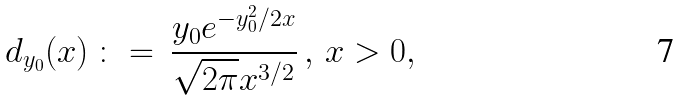Convert formula to latex. <formula><loc_0><loc_0><loc_500><loc_500>d _ { y _ { 0 } } ( x ) \, \colon = \, \frac { y _ { 0 } e ^ { - y _ { 0 } ^ { 2 } / 2 x } } { \sqrt { 2 \pi } x ^ { 3 / 2 } } \, , \, x > 0 ,</formula> 